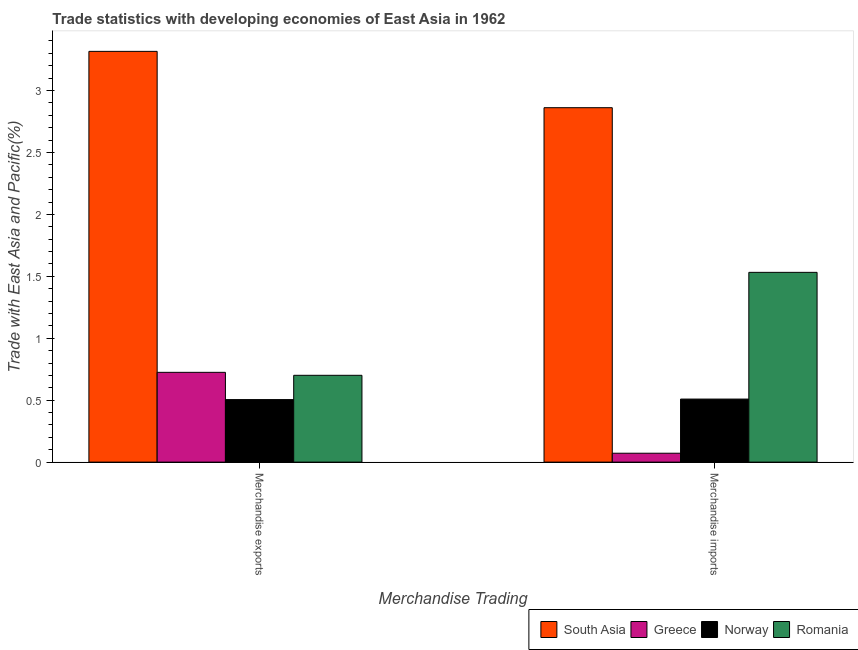Are the number of bars per tick equal to the number of legend labels?
Your answer should be compact. Yes. Are the number of bars on each tick of the X-axis equal?
Offer a terse response. Yes. How many bars are there on the 1st tick from the left?
Ensure brevity in your answer.  4. How many bars are there on the 2nd tick from the right?
Make the answer very short. 4. What is the merchandise exports in South Asia?
Offer a very short reply. 3.32. Across all countries, what is the maximum merchandise imports?
Give a very brief answer. 2.86. Across all countries, what is the minimum merchandise exports?
Provide a short and direct response. 0.5. In which country was the merchandise imports maximum?
Your answer should be very brief. South Asia. In which country was the merchandise imports minimum?
Offer a terse response. Greece. What is the total merchandise exports in the graph?
Keep it short and to the point. 5.25. What is the difference between the merchandise exports in Romania and that in Norway?
Give a very brief answer. 0.2. What is the difference between the merchandise imports in Norway and the merchandise exports in South Asia?
Provide a succinct answer. -2.81. What is the average merchandise imports per country?
Keep it short and to the point. 1.24. What is the difference between the merchandise imports and merchandise exports in Romania?
Your answer should be very brief. 0.83. What is the ratio of the merchandise imports in Norway to that in Greece?
Provide a short and direct response. 7.09. In how many countries, is the merchandise exports greater than the average merchandise exports taken over all countries?
Ensure brevity in your answer.  1. What does the 1st bar from the left in Merchandise exports represents?
Give a very brief answer. South Asia. How many countries are there in the graph?
Provide a short and direct response. 4. Does the graph contain any zero values?
Offer a very short reply. No. Does the graph contain grids?
Make the answer very short. No. Where does the legend appear in the graph?
Ensure brevity in your answer.  Bottom right. What is the title of the graph?
Your answer should be compact. Trade statistics with developing economies of East Asia in 1962. Does "European Union" appear as one of the legend labels in the graph?
Ensure brevity in your answer.  No. What is the label or title of the X-axis?
Ensure brevity in your answer.  Merchandise Trading. What is the label or title of the Y-axis?
Give a very brief answer. Trade with East Asia and Pacific(%). What is the Trade with East Asia and Pacific(%) in South Asia in Merchandise exports?
Keep it short and to the point. 3.32. What is the Trade with East Asia and Pacific(%) in Greece in Merchandise exports?
Offer a terse response. 0.72. What is the Trade with East Asia and Pacific(%) in Norway in Merchandise exports?
Make the answer very short. 0.5. What is the Trade with East Asia and Pacific(%) of Romania in Merchandise exports?
Your answer should be very brief. 0.7. What is the Trade with East Asia and Pacific(%) in South Asia in Merchandise imports?
Provide a short and direct response. 2.86. What is the Trade with East Asia and Pacific(%) in Greece in Merchandise imports?
Provide a succinct answer. 0.07. What is the Trade with East Asia and Pacific(%) in Norway in Merchandise imports?
Make the answer very short. 0.51. What is the Trade with East Asia and Pacific(%) in Romania in Merchandise imports?
Your answer should be compact. 1.53. Across all Merchandise Trading, what is the maximum Trade with East Asia and Pacific(%) of South Asia?
Offer a very short reply. 3.32. Across all Merchandise Trading, what is the maximum Trade with East Asia and Pacific(%) of Greece?
Your answer should be very brief. 0.72. Across all Merchandise Trading, what is the maximum Trade with East Asia and Pacific(%) in Norway?
Your response must be concise. 0.51. Across all Merchandise Trading, what is the maximum Trade with East Asia and Pacific(%) of Romania?
Provide a short and direct response. 1.53. Across all Merchandise Trading, what is the minimum Trade with East Asia and Pacific(%) of South Asia?
Provide a short and direct response. 2.86. Across all Merchandise Trading, what is the minimum Trade with East Asia and Pacific(%) in Greece?
Offer a terse response. 0.07. Across all Merchandise Trading, what is the minimum Trade with East Asia and Pacific(%) in Norway?
Your answer should be very brief. 0.5. Across all Merchandise Trading, what is the minimum Trade with East Asia and Pacific(%) of Romania?
Ensure brevity in your answer.  0.7. What is the total Trade with East Asia and Pacific(%) of South Asia in the graph?
Give a very brief answer. 6.18. What is the total Trade with East Asia and Pacific(%) of Greece in the graph?
Provide a succinct answer. 0.8. What is the total Trade with East Asia and Pacific(%) of Norway in the graph?
Your response must be concise. 1.01. What is the total Trade with East Asia and Pacific(%) of Romania in the graph?
Provide a short and direct response. 2.23. What is the difference between the Trade with East Asia and Pacific(%) of South Asia in Merchandise exports and that in Merchandise imports?
Make the answer very short. 0.45. What is the difference between the Trade with East Asia and Pacific(%) of Greece in Merchandise exports and that in Merchandise imports?
Make the answer very short. 0.65. What is the difference between the Trade with East Asia and Pacific(%) in Norway in Merchandise exports and that in Merchandise imports?
Make the answer very short. -0. What is the difference between the Trade with East Asia and Pacific(%) of Romania in Merchandise exports and that in Merchandise imports?
Your response must be concise. -0.83. What is the difference between the Trade with East Asia and Pacific(%) in South Asia in Merchandise exports and the Trade with East Asia and Pacific(%) in Greece in Merchandise imports?
Provide a short and direct response. 3.24. What is the difference between the Trade with East Asia and Pacific(%) of South Asia in Merchandise exports and the Trade with East Asia and Pacific(%) of Norway in Merchandise imports?
Offer a terse response. 2.81. What is the difference between the Trade with East Asia and Pacific(%) in South Asia in Merchandise exports and the Trade with East Asia and Pacific(%) in Romania in Merchandise imports?
Your answer should be compact. 1.78. What is the difference between the Trade with East Asia and Pacific(%) in Greece in Merchandise exports and the Trade with East Asia and Pacific(%) in Norway in Merchandise imports?
Provide a short and direct response. 0.22. What is the difference between the Trade with East Asia and Pacific(%) of Greece in Merchandise exports and the Trade with East Asia and Pacific(%) of Romania in Merchandise imports?
Provide a succinct answer. -0.81. What is the difference between the Trade with East Asia and Pacific(%) in Norway in Merchandise exports and the Trade with East Asia and Pacific(%) in Romania in Merchandise imports?
Provide a succinct answer. -1.03. What is the average Trade with East Asia and Pacific(%) of South Asia per Merchandise Trading?
Offer a terse response. 3.09. What is the average Trade with East Asia and Pacific(%) of Greece per Merchandise Trading?
Make the answer very short. 0.4. What is the average Trade with East Asia and Pacific(%) in Norway per Merchandise Trading?
Provide a succinct answer. 0.51. What is the average Trade with East Asia and Pacific(%) of Romania per Merchandise Trading?
Provide a short and direct response. 1.12. What is the difference between the Trade with East Asia and Pacific(%) in South Asia and Trade with East Asia and Pacific(%) in Greece in Merchandise exports?
Make the answer very short. 2.59. What is the difference between the Trade with East Asia and Pacific(%) in South Asia and Trade with East Asia and Pacific(%) in Norway in Merchandise exports?
Ensure brevity in your answer.  2.81. What is the difference between the Trade with East Asia and Pacific(%) of South Asia and Trade with East Asia and Pacific(%) of Romania in Merchandise exports?
Ensure brevity in your answer.  2.62. What is the difference between the Trade with East Asia and Pacific(%) in Greece and Trade with East Asia and Pacific(%) in Norway in Merchandise exports?
Provide a short and direct response. 0.22. What is the difference between the Trade with East Asia and Pacific(%) in Greece and Trade with East Asia and Pacific(%) in Romania in Merchandise exports?
Provide a short and direct response. 0.02. What is the difference between the Trade with East Asia and Pacific(%) in Norway and Trade with East Asia and Pacific(%) in Romania in Merchandise exports?
Make the answer very short. -0.2. What is the difference between the Trade with East Asia and Pacific(%) in South Asia and Trade with East Asia and Pacific(%) in Greece in Merchandise imports?
Provide a short and direct response. 2.79. What is the difference between the Trade with East Asia and Pacific(%) in South Asia and Trade with East Asia and Pacific(%) in Norway in Merchandise imports?
Your answer should be very brief. 2.35. What is the difference between the Trade with East Asia and Pacific(%) in South Asia and Trade with East Asia and Pacific(%) in Romania in Merchandise imports?
Offer a terse response. 1.33. What is the difference between the Trade with East Asia and Pacific(%) in Greece and Trade with East Asia and Pacific(%) in Norway in Merchandise imports?
Your answer should be compact. -0.44. What is the difference between the Trade with East Asia and Pacific(%) in Greece and Trade with East Asia and Pacific(%) in Romania in Merchandise imports?
Your response must be concise. -1.46. What is the difference between the Trade with East Asia and Pacific(%) of Norway and Trade with East Asia and Pacific(%) of Romania in Merchandise imports?
Give a very brief answer. -1.02. What is the ratio of the Trade with East Asia and Pacific(%) in South Asia in Merchandise exports to that in Merchandise imports?
Make the answer very short. 1.16. What is the ratio of the Trade with East Asia and Pacific(%) in Greece in Merchandise exports to that in Merchandise imports?
Provide a short and direct response. 10.1. What is the ratio of the Trade with East Asia and Pacific(%) of Romania in Merchandise exports to that in Merchandise imports?
Offer a terse response. 0.46. What is the difference between the highest and the second highest Trade with East Asia and Pacific(%) in South Asia?
Your answer should be very brief. 0.45. What is the difference between the highest and the second highest Trade with East Asia and Pacific(%) of Greece?
Offer a terse response. 0.65. What is the difference between the highest and the second highest Trade with East Asia and Pacific(%) in Norway?
Make the answer very short. 0. What is the difference between the highest and the second highest Trade with East Asia and Pacific(%) in Romania?
Your answer should be very brief. 0.83. What is the difference between the highest and the lowest Trade with East Asia and Pacific(%) in South Asia?
Provide a short and direct response. 0.45. What is the difference between the highest and the lowest Trade with East Asia and Pacific(%) in Greece?
Make the answer very short. 0.65. What is the difference between the highest and the lowest Trade with East Asia and Pacific(%) of Norway?
Give a very brief answer. 0. What is the difference between the highest and the lowest Trade with East Asia and Pacific(%) of Romania?
Offer a terse response. 0.83. 